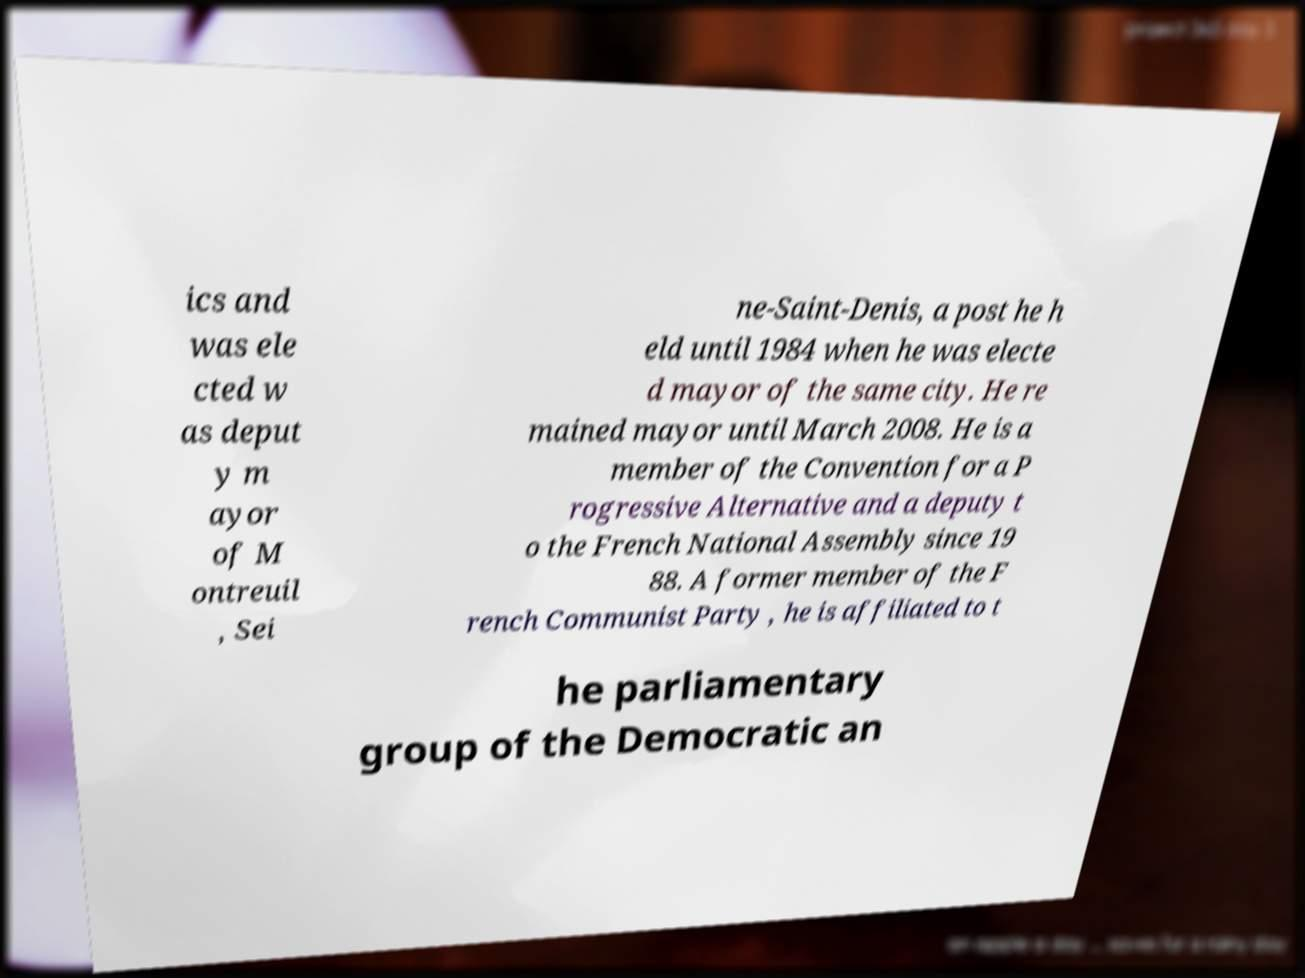For documentation purposes, I need the text within this image transcribed. Could you provide that? ics and was ele cted w as deput y m ayor of M ontreuil , Sei ne-Saint-Denis, a post he h eld until 1984 when he was electe d mayor of the same city. He re mained mayor until March 2008. He is a member of the Convention for a P rogressive Alternative and a deputy t o the French National Assembly since 19 88. A former member of the F rench Communist Party , he is affiliated to t he parliamentary group of the Democratic an 